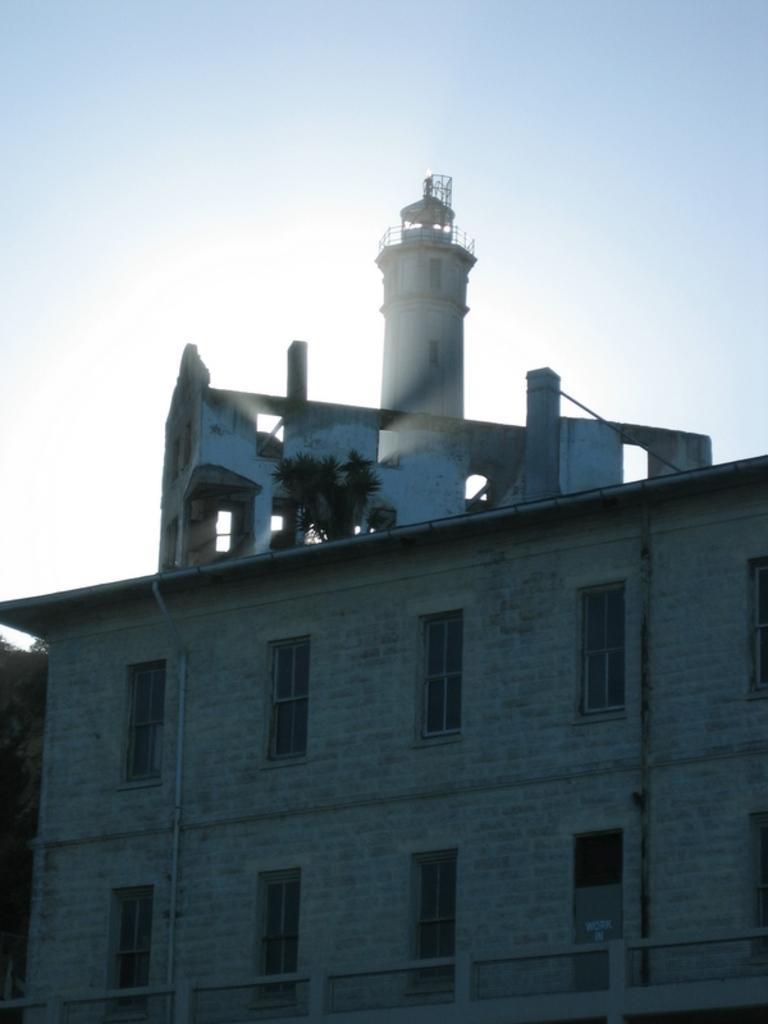Can you describe this image briefly? This image consists of a building to which there are many windows. At the top, we can see a tower and there is a sky. 